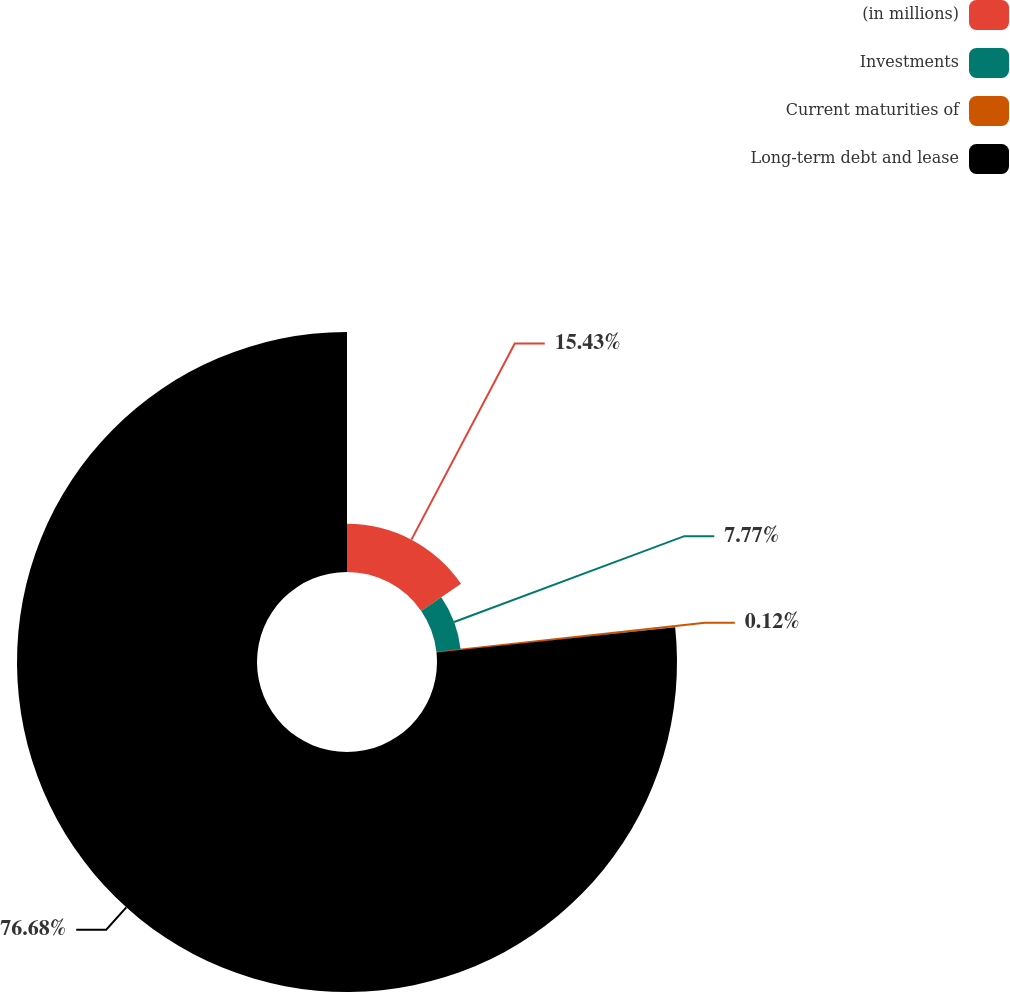Convert chart. <chart><loc_0><loc_0><loc_500><loc_500><pie_chart><fcel>(in millions)<fcel>Investments<fcel>Current maturities of<fcel>Long-term debt and lease<nl><fcel>15.43%<fcel>7.77%<fcel>0.12%<fcel>76.68%<nl></chart> 